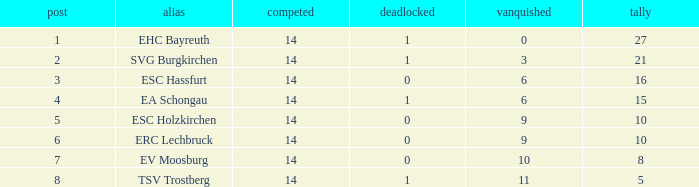What's the points that has a lost more 6, played less than 14 and a position more than 1? None. 